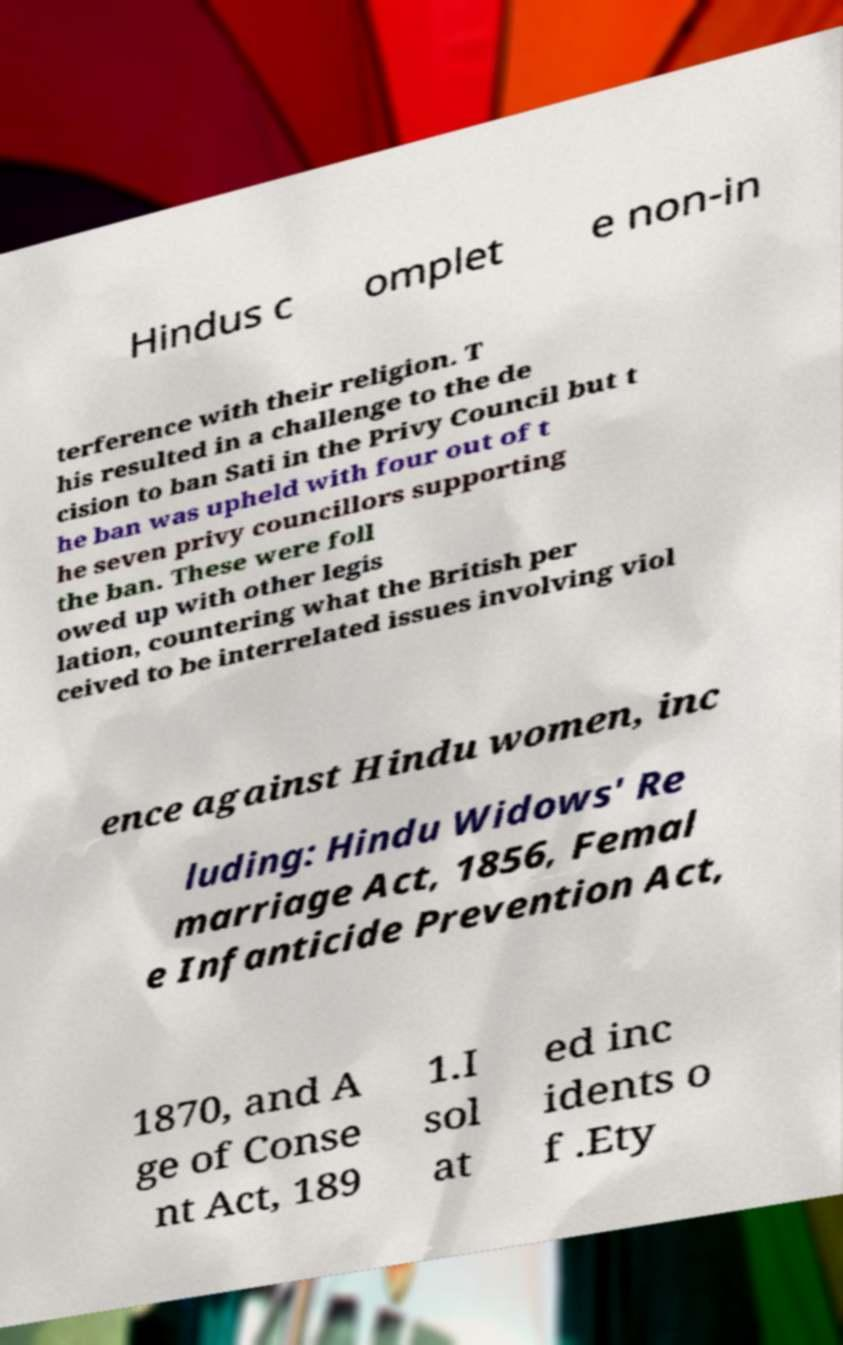Can you read and provide the text displayed in the image?This photo seems to have some interesting text. Can you extract and type it out for me? Hindus c omplet e non-in terference with their religion. T his resulted in a challenge to the de cision to ban Sati in the Privy Council but t he ban was upheld with four out of t he seven privy councillors supporting the ban. These were foll owed up with other legis lation, countering what the British per ceived to be interrelated issues involving viol ence against Hindu women, inc luding: Hindu Widows' Re marriage Act, 1856, Femal e Infanticide Prevention Act, 1870, and A ge of Conse nt Act, 189 1.I sol at ed inc idents o f .Ety 